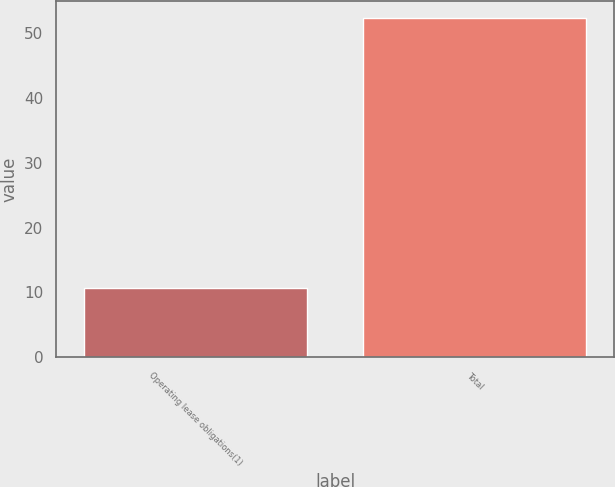Convert chart. <chart><loc_0><loc_0><loc_500><loc_500><bar_chart><fcel>Operating lease obligations(1)<fcel>Total<nl><fcel>10.7<fcel>52.3<nl></chart> 